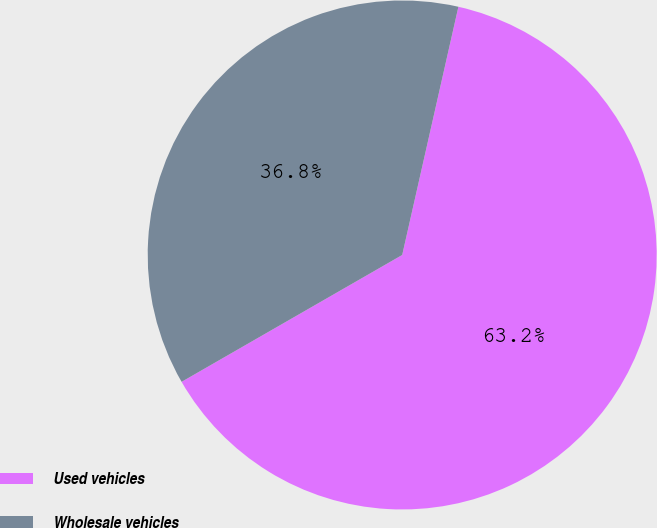Convert chart. <chart><loc_0><loc_0><loc_500><loc_500><pie_chart><fcel>Used vehicles<fcel>Wholesale vehicles<nl><fcel>63.15%<fcel>36.85%<nl></chart> 